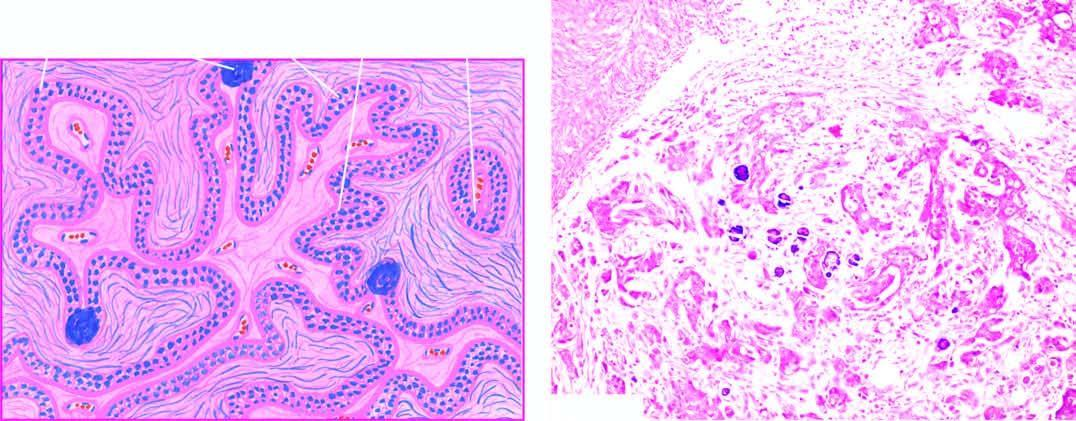does the stroma show invasion by clusters of anaplastic tumour cells?
Answer the question using a single word or phrase. Yes 